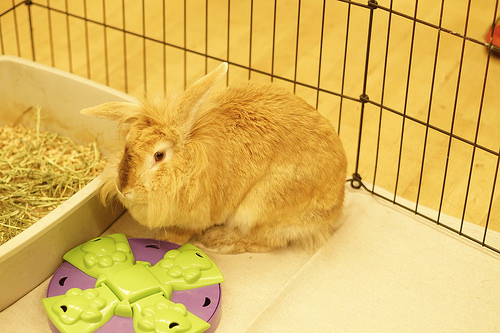<image>
Is the rabbit in the cage? Yes. The rabbit is contained within or inside the cage, showing a containment relationship. Is the rabbit in front of the barrier? Yes. The rabbit is positioned in front of the barrier, appearing closer to the camera viewpoint. 